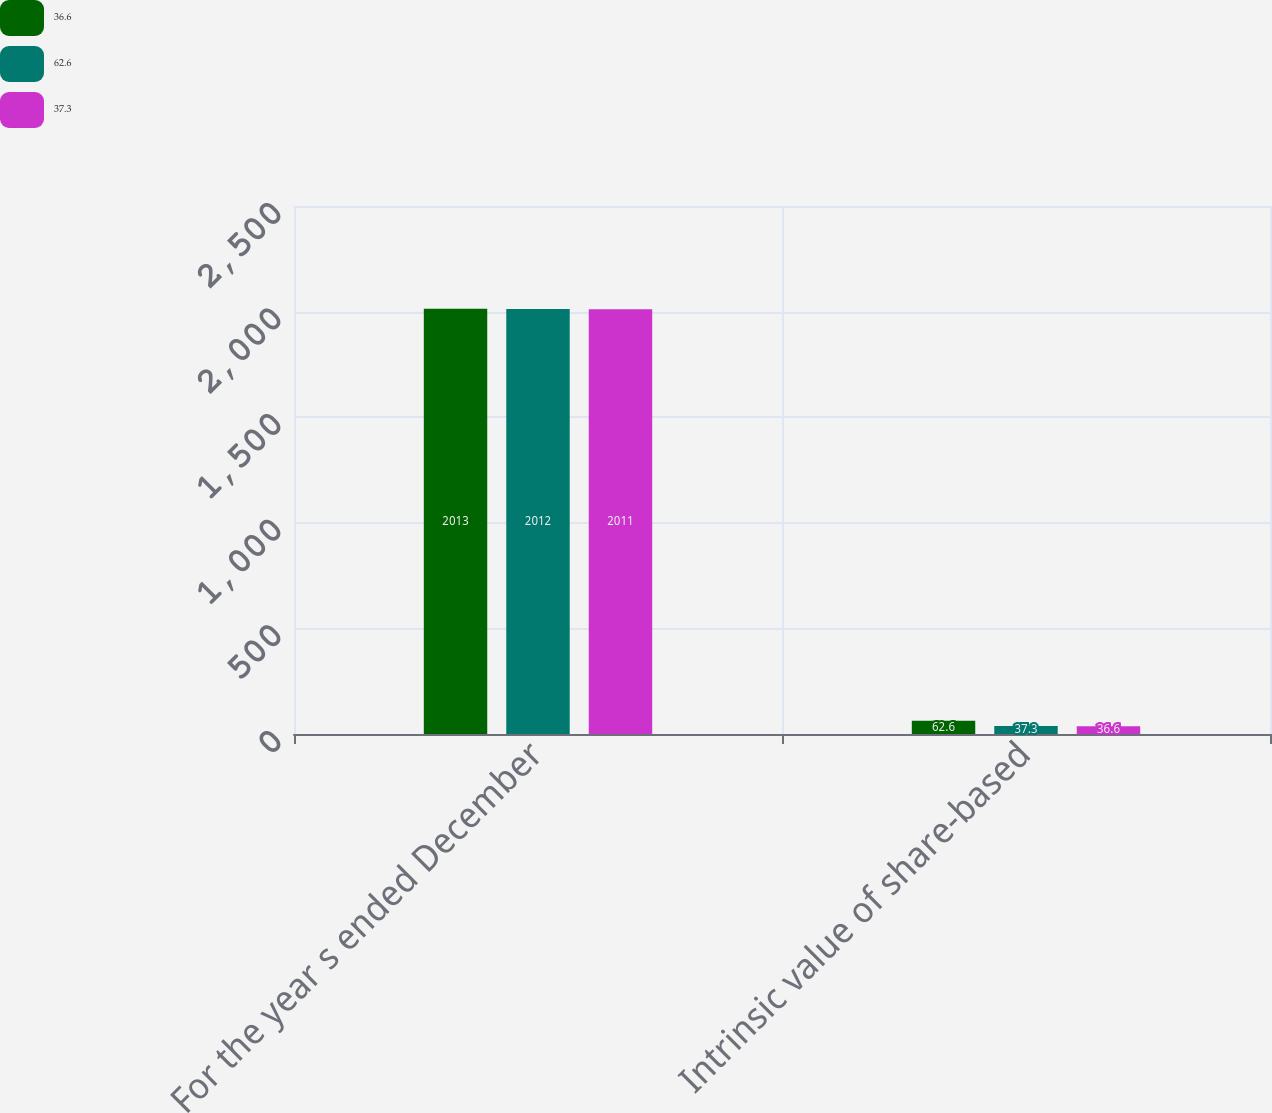<chart> <loc_0><loc_0><loc_500><loc_500><stacked_bar_chart><ecel><fcel>For the year s ended December<fcel>Intrinsic value of share-based<nl><fcel>36.6<fcel>2013<fcel>62.6<nl><fcel>62.6<fcel>2012<fcel>37.3<nl><fcel>37.3<fcel>2011<fcel>36.6<nl></chart> 